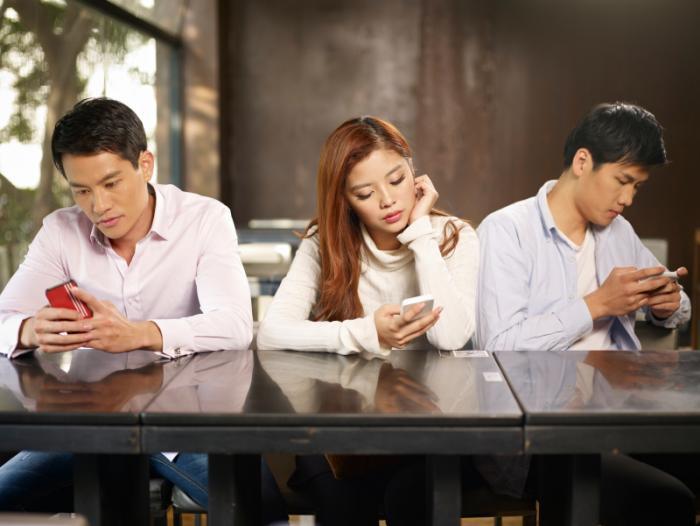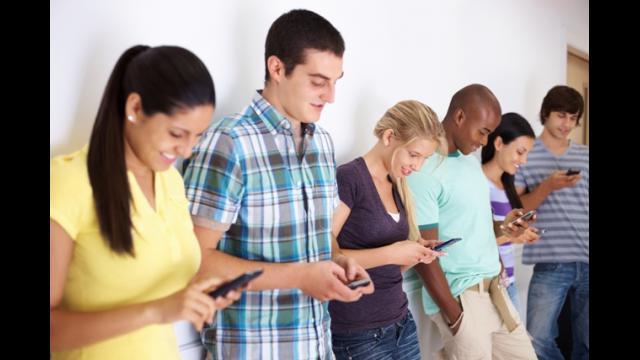The first image is the image on the left, the second image is the image on the right. Evaluate the accuracy of this statement regarding the images: "Three people are sitting together looking at their phones in the image on the right.". Is it true? Answer yes or no. No. The first image is the image on the left, the second image is the image on the right. For the images displayed, is the sentence "there are three people sitting at a shiny brown table looking at their phones, there are two men on the outside and a woman in the center" factually correct? Answer yes or no. Yes. 